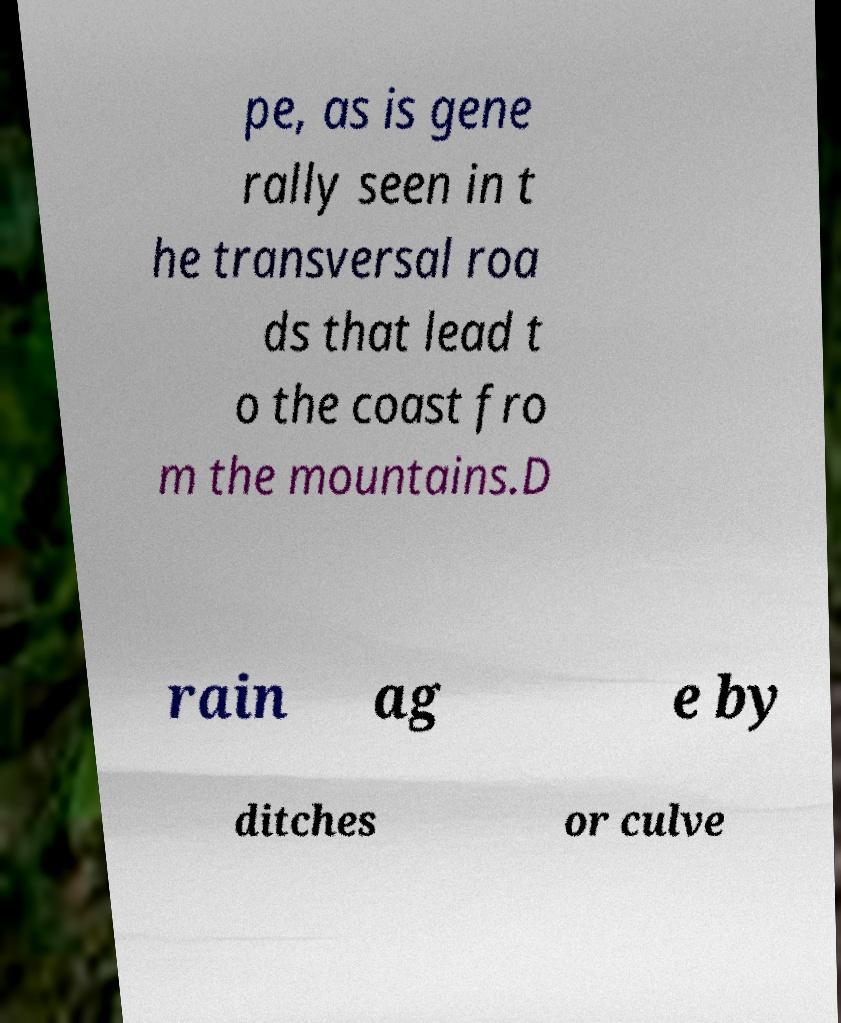Please identify and transcribe the text found in this image. pe, as is gene rally seen in t he transversal roa ds that lead t o the coast fro m the mountains.D rain ag e by ditches or culve 